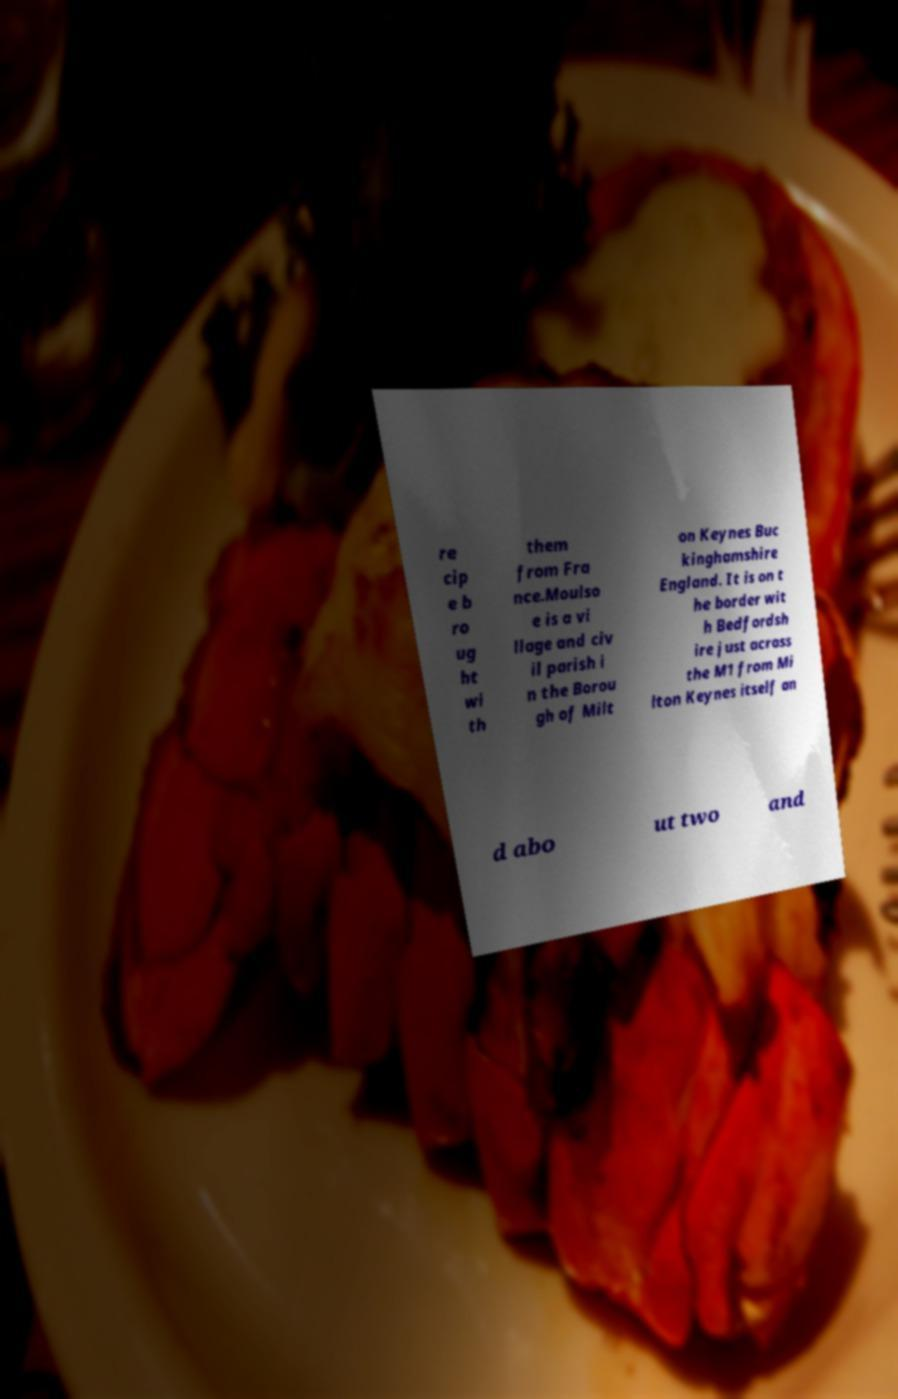Please identify and transcribe the text found in this image. re cip e b ro ug ht wi th them from Fra nce.Moulso e is a vi llage and civ il parish i n the Borou gh of Milt on Keynes Buc kinghamshire England. It is on t he border wit h Bedfordsh ire just across the M1 from Mi lton Keynes itself an d abo ut two and 